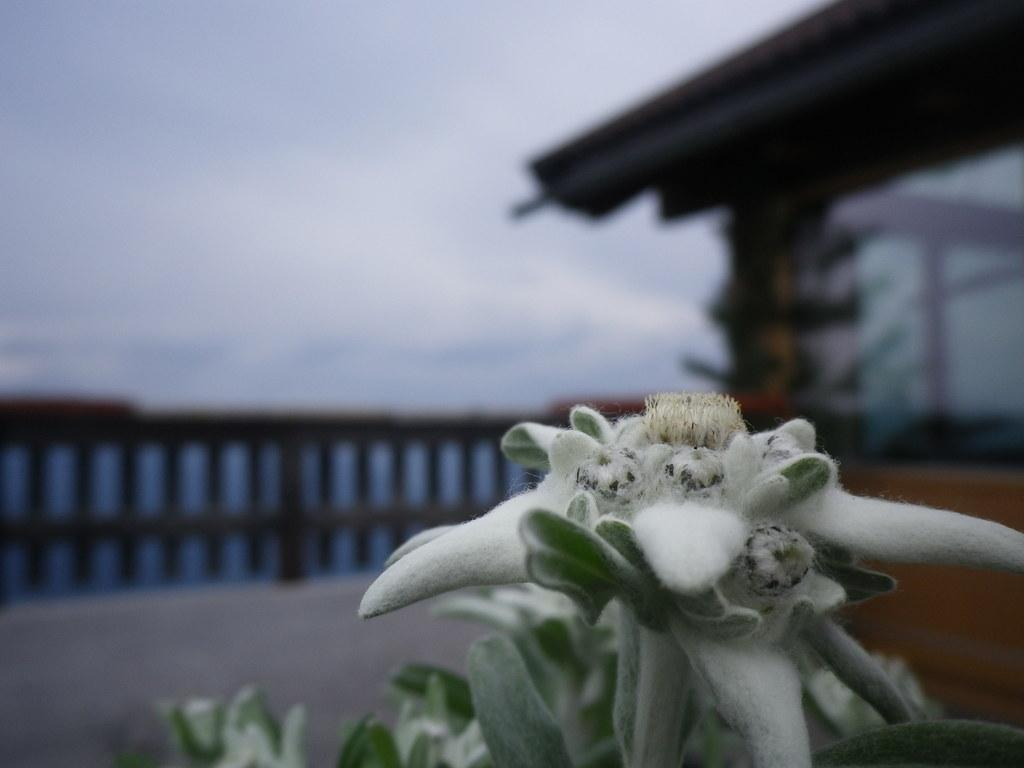What type of vegetation is present in the image? There are green color leaves in the image. What can be seen in the background of the image? There is a building and the sky visible in the background of the image. How is the image's background quality? The image is slightly blurry in the background. What type of approval is required for the vessel in the image? There is no vessel present in the image, so the question of approval is not applicable. 